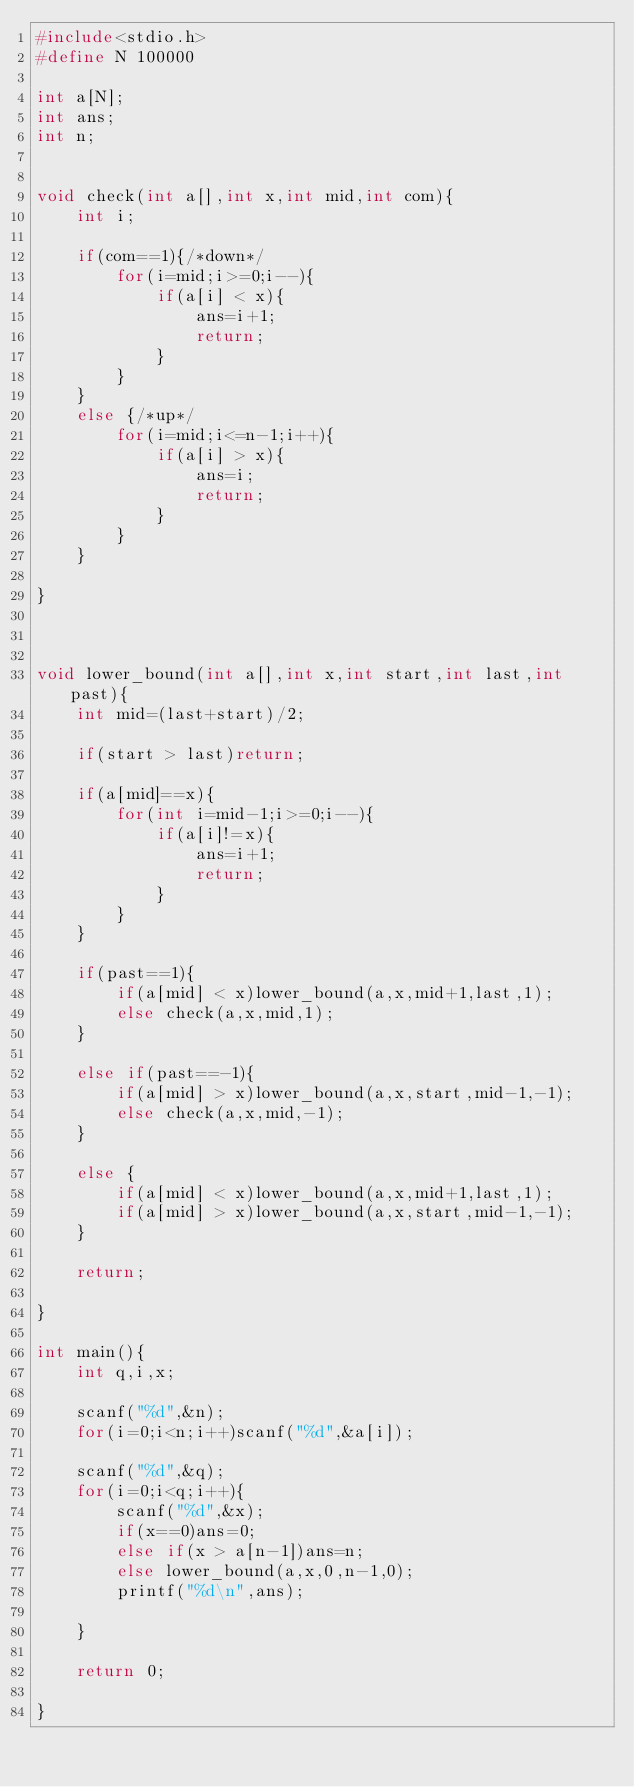<code> <loc_0><loc_0><loc_500><loc_500><_C_>#include<stdio.h>
#define N 100000

int a[N];
int ans;
int n;


void check(int a[],int x,int mid,int com){
	int i;
	
	if(com==1){/*down*/
		for(i=mid;i>=0;i--){
			if(a[i] < x){
				ans=i+1;
				return;
			}
		}
	}
	else {/*up*/
		for(i=mid;i<=n-1;i++){
			if(a[i] > x){
				ans=i;
				return;
			}
		}
	}

}
		


void lower_bound(int a[],int x,int start,int last,int past){
	int mid=(last+start)/2;
	
	if(start > last)return;
	
	if(a[mid]==x){
		for(int i=mid-1;i>=0;i--){
			if(a[i]!=x){
				ans=i+1;
				return;
			}
		}
	}
	
	if(past==1){
		if(a[mid] < x)lower_bound(a,x,mid+1,last,1);
		else check(a,x,mid,1);
	}
	
	else if(past==-1){
		if(a[mid] > x)lower_bound(a,x,start,mid-1,-1);
		else check(a,x,mid,-1);
	}
	
	else {
		if(a[mid] < x)lower_bound(a,x,mid+1,last,1);
		if(a[mid] > x)lower_bound(a,x,start,mid-1,-1);
	}
	
	return;
	
}

int main(){
	int q,i,x;
	
	scanf("%d",&n);
	for(i=0;i<n;i++)scanf("%d",&a[i]);
	
	scanf("%d",&q);
	for(i=0;i<q;i++){
		scanf("%d",&x);
		if(x==0)ans=0;
		else if(x > a[n-1])ans=n;
		else lower_bound(a,x,0,n-1,0);
		printf("%d\n",ans);
		
	}
	
	return 0;
	
}
</code> 